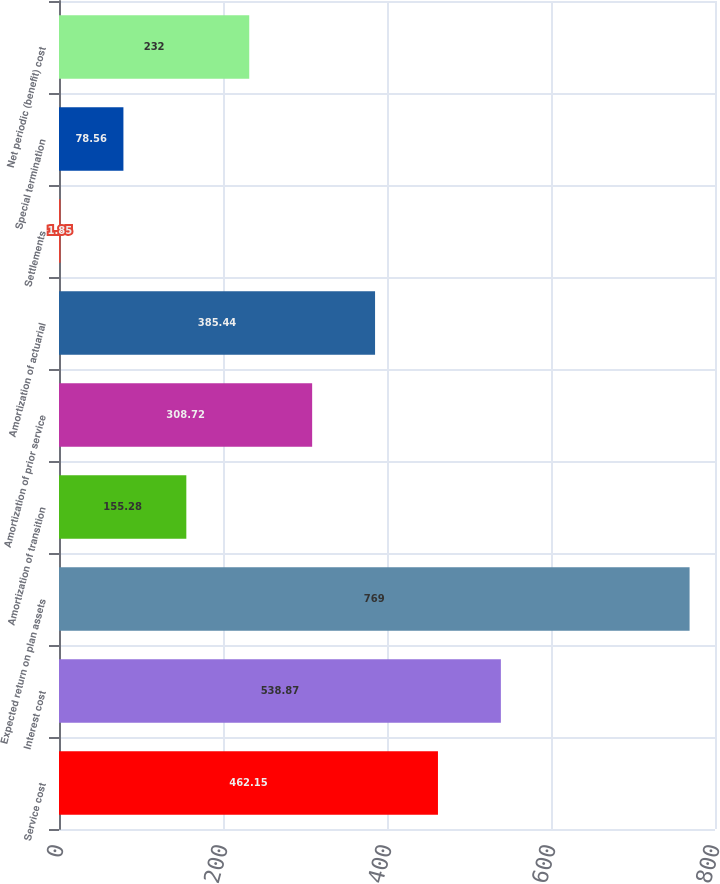Convert chart. <chart><loc_0><loc_0><loc_500><loc_500><bar_chart><fcel>Service cost<fcel>Interest cost<fcel>Expected return on plan assets<fcel>Amortization of transition<fcel>Amortization of prior service<fcel>Amortization of actuarial<fcel>Settlements<fcel>Special termination<fcel>Net periodic (benefit) cost<nl><fcel>462.15<fcel>538.87<fcel>769<fcel>155.28<fcel>308.72<fcel>385.44<fcel>1.85<fcel>78.56<fcel>232<nl></chart> 